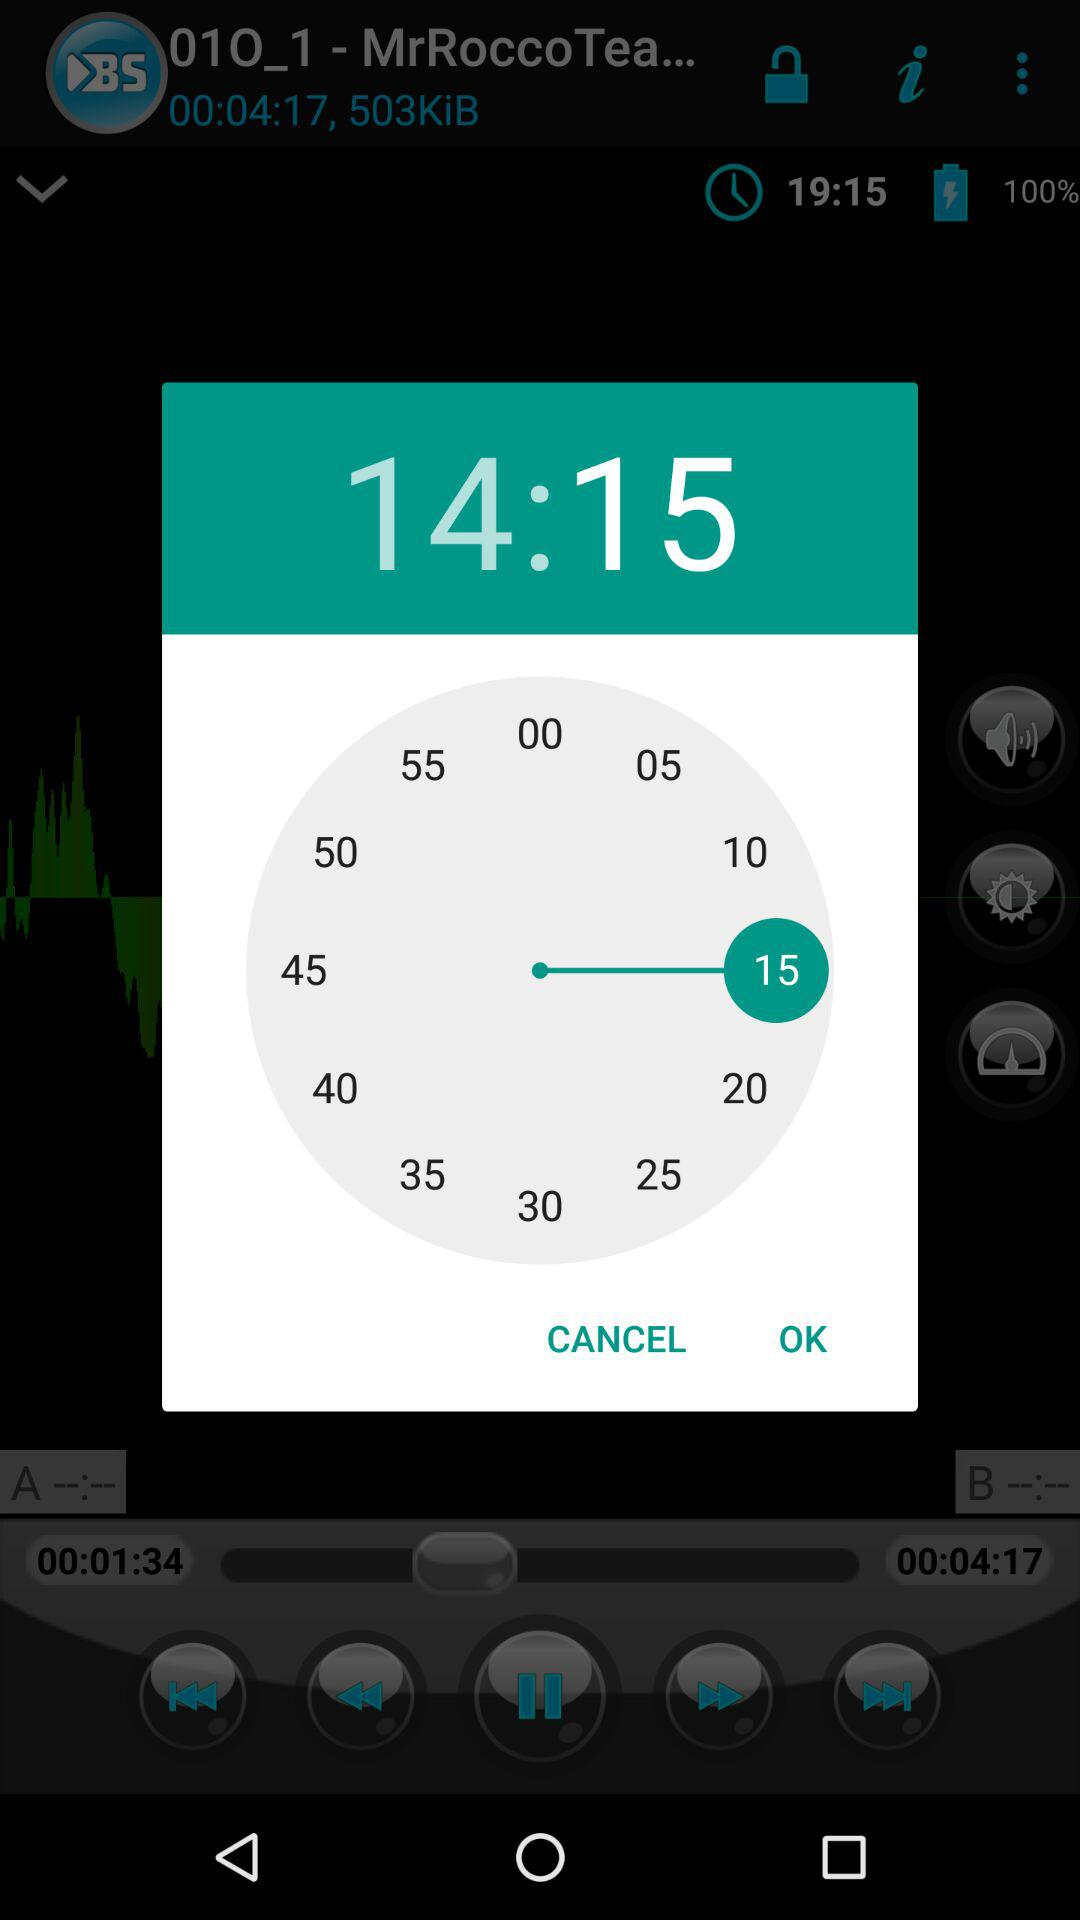What is the selected date?
When the provided information is insufficient, respond with <no answer>. <no answer> 